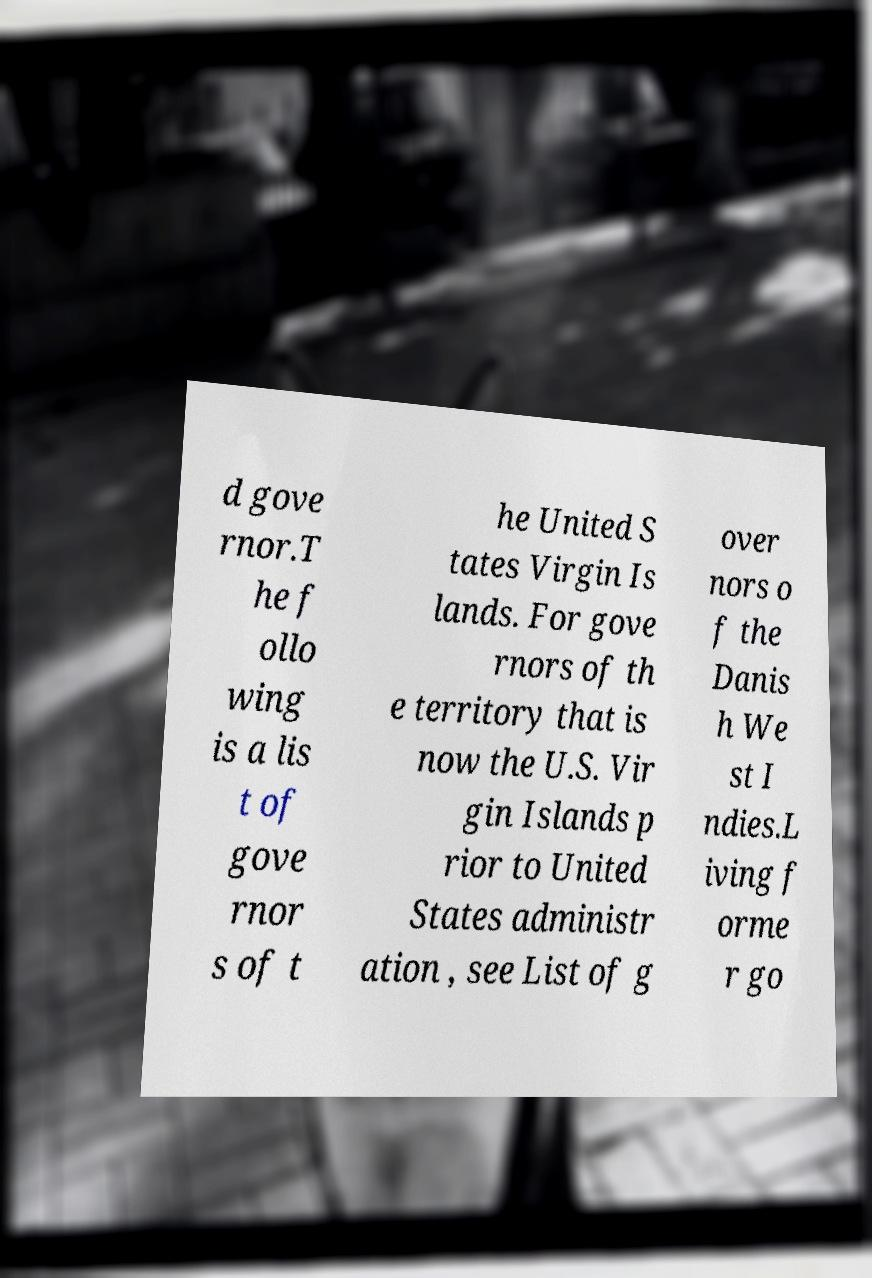I need the written content from this picture converted into text. Can you do that? d gove rnor.T he f ollo wing is a lis t of gove rnor s of t he United S tates Virgin Is lands. For gove rnors of th e territory that is now the U.S. Vir gin Islands p rior to United States administr ation , see List of g over nors o f the Danis h We st I ndies.L iving f orme r go 